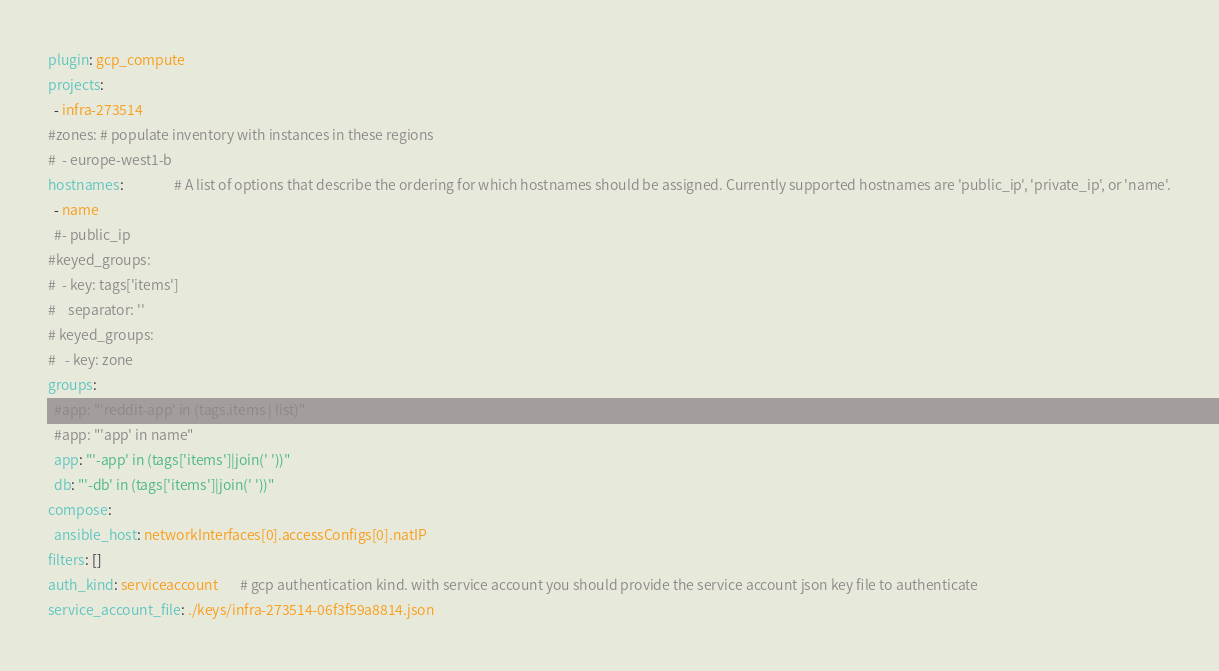Convert code to text. <code><loc_0><loc_0><loc_500><loc_500><_YAML_>plugin: gcp_compute
projects:
  - infra-273514
#zones: # populate inventory with instances in these regions
#  - europe-west1-b
hostnames:                # A list of options that describe the ordering for which hostnames should be assigned. Currently supported hostnames are 'public_ip', 'private_ip', or 'name'.
  - name
  #- public_ip
#keyed_groups:
#  - key: tags['items']
#    separator: ''
# keyed_groups:
#   - key: zone
groups:
  #app: "'reddit-app' in (tags.items | list)"
  #app: "'app' in name"
  app: "'-app' in (tags['items']|join(' '))"
  db: "'-db' in (tags['items']|join(' '))"
compose:
  ansible_host: networkInterfaces[0].accessConfigs[0].natIP
filters: []
auth_kind: serviceaccount       # gcp authentication kind. with service account you should provide the service account json key file to authenticate
service_account_file: ./keys/infra-273514-06f3f59a8814.json
</code> 